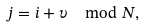<formula> <loc_0><loc_0><loc_500><loc_500>j = i + \upsilon \mod N ,</formula> 